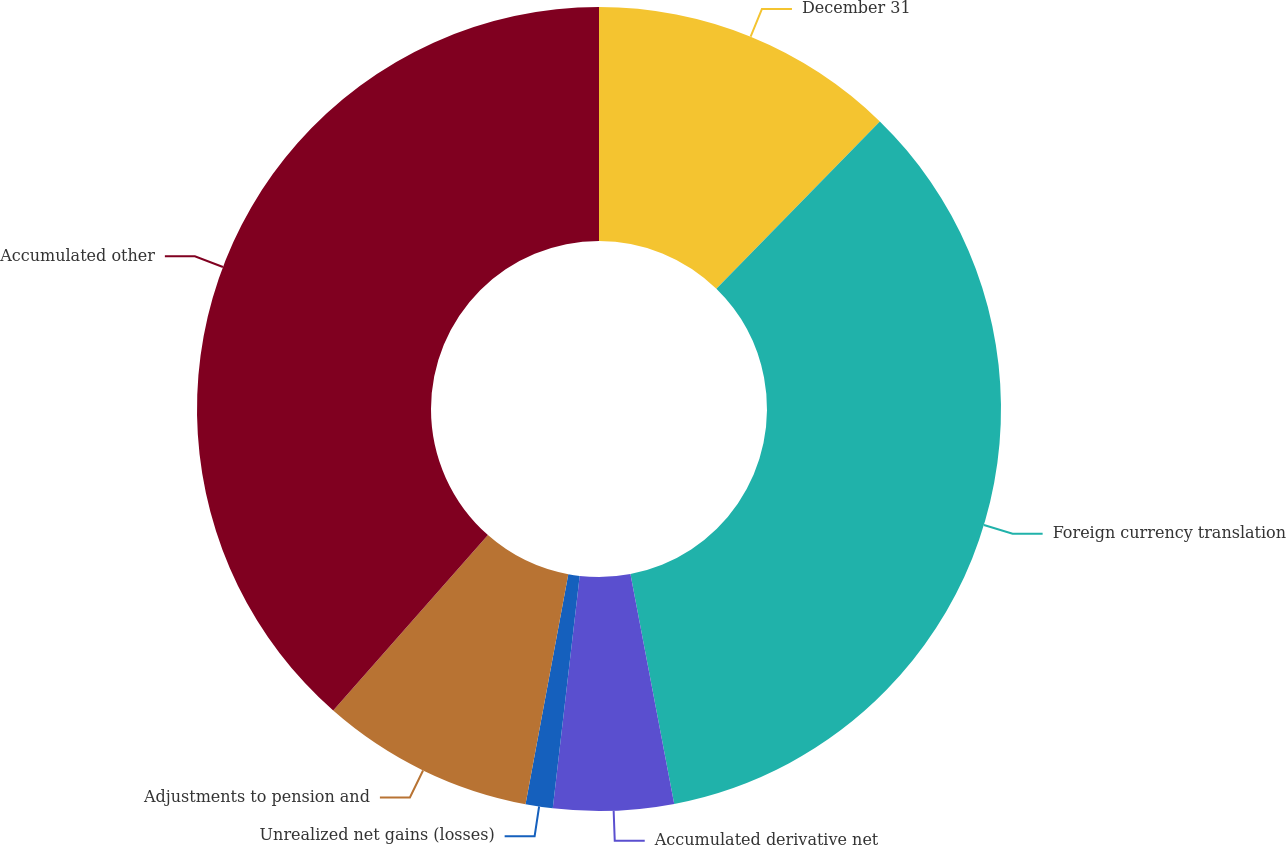Convert chart. <chart><loc_0><loc_0><loc_500><loc_500><pie_chart><fcel>December 31<fcel>Foreign currency translation<fcel>Accumulated derivative net<fcel>Unrealized net gains (losses)<fcel>Adjustments to pension and<fcel>Accumulated other<nl><fcel>12.31%<fcel>34.69%<fcel>4.83%<fcel>1.09%<fcel>8.57%<fcel>38.5%<nl></chart> 